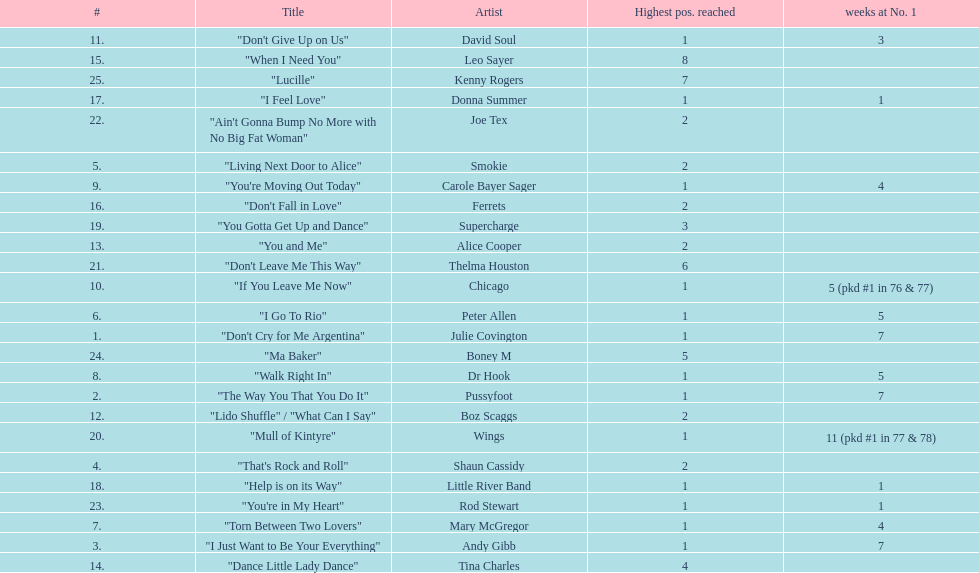Who had the most weeks at number one, according to the table? Wings. 